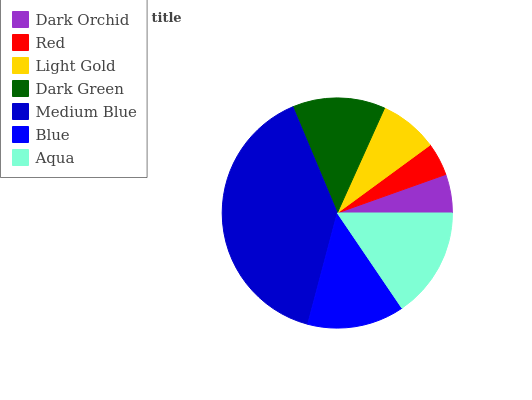Is Red the minimum?
Answer yes or no. Yes. Is Medium Blue the maximum?
Answer yes or no. Yes. Is Light Gold the minimum?
Answer yes or no. No. Is Light Gold the maximum?
Answer yes or no. No. Is Light Gold greater than Red?
Answer yes or no. Yes. Is Red less than Light Gold?
Answer yes or no. Yes. Is Red greater than Light Gold?
Answer yes or no. No. Is Light Gold less than Red?
Answer yes or no. No. Is Dark Green the high median?
Answer yes or no. Yes. Is Dark Green the low median?
Answer yes or no. Yes. Is Dark Orchid the high median?
Answer yes or no. No. Is Blue the low median?
Answer yes or no. No. 